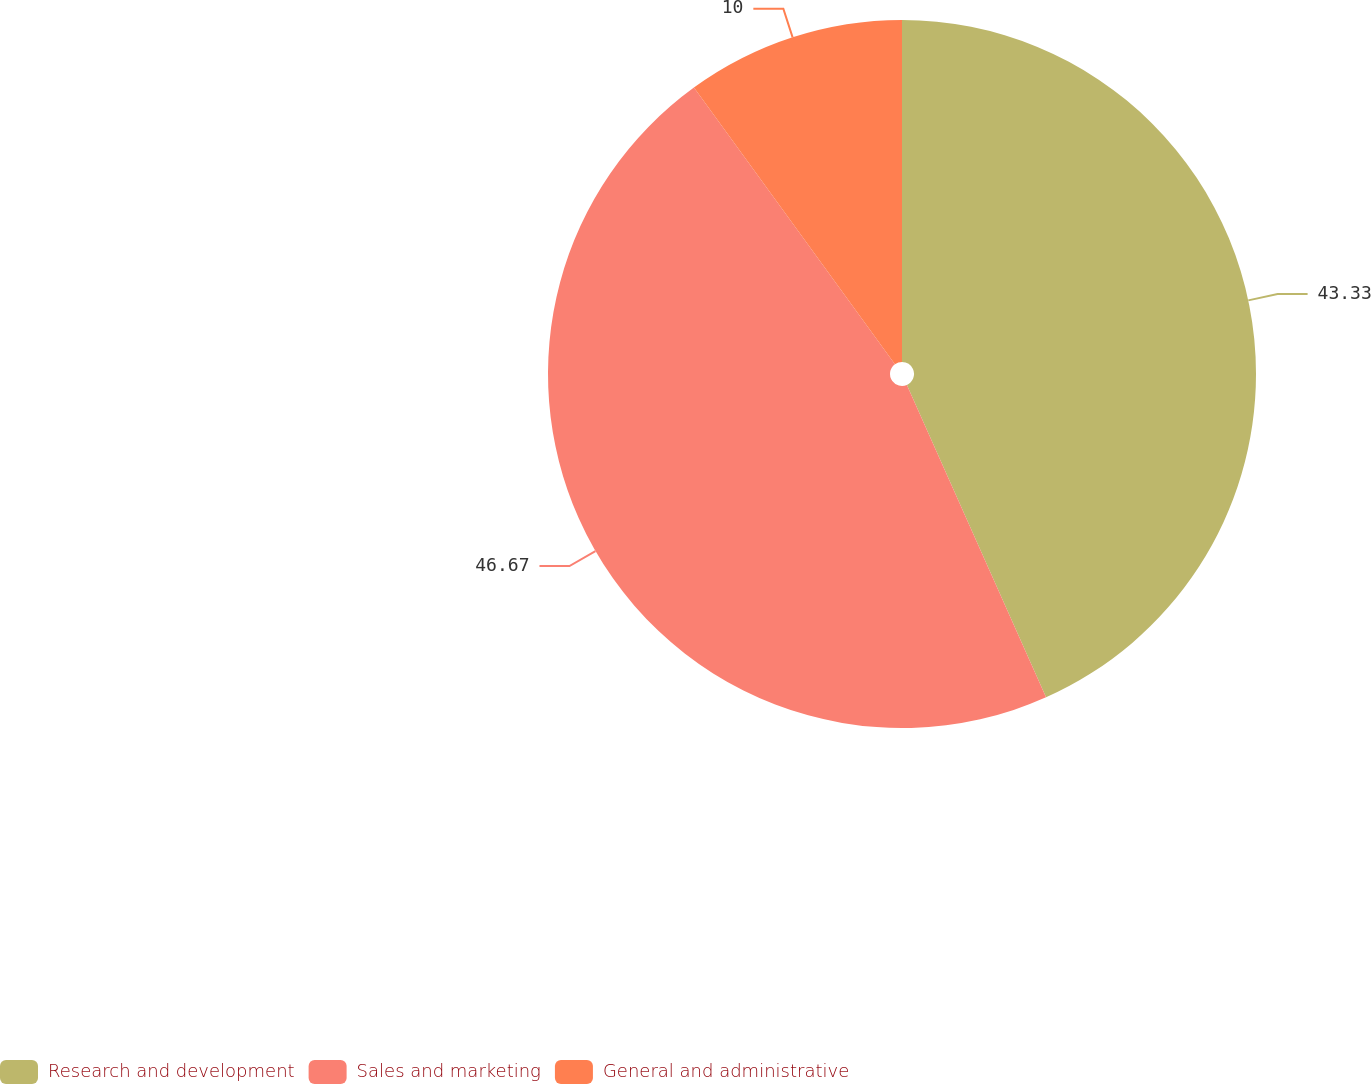Convert chart. <chart><loc_0><loc_0><loc_500><loc_500><pie_chart><fcel>Research and development<fcel>Sales and marketing<fcel>General and administrative<nl><fcel>43.33%<fcel>46.67%<fcel>10.0%<nl></chart> 